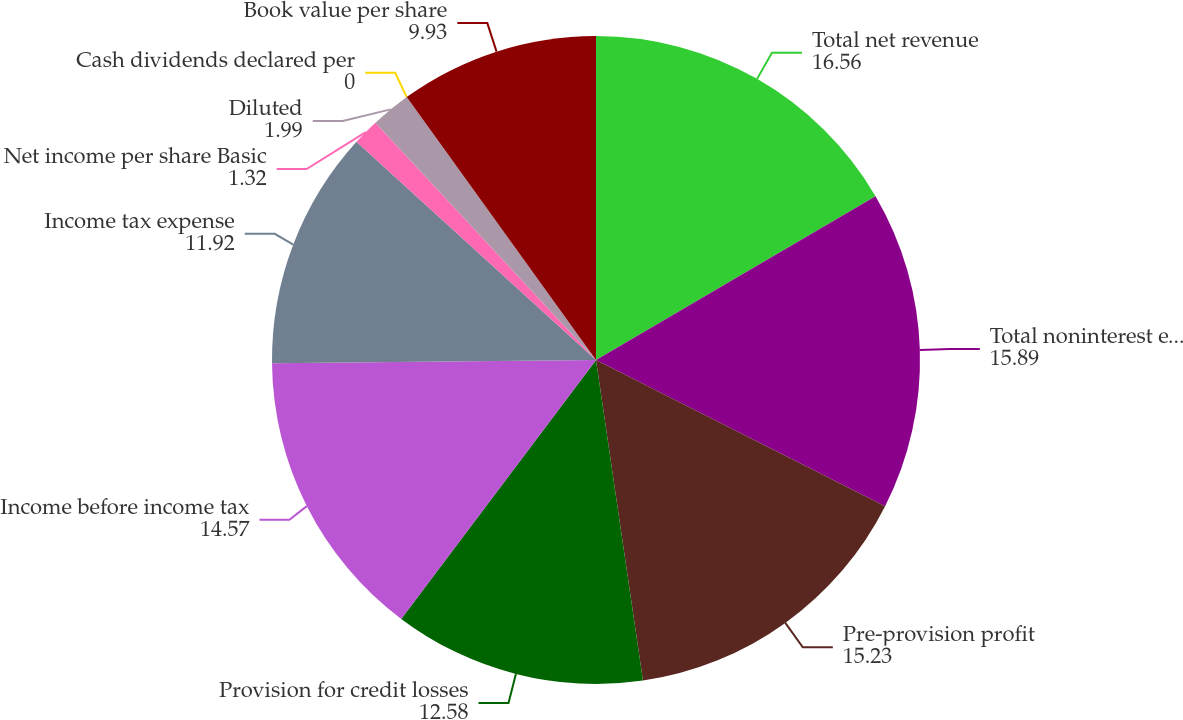Convert chart. <chart><loc_0><loc_0><loc_500><loc_500><pie_chart><fcel>Total net revenue<fcel>Total noninterest expense<fcel>Pre-provision profit<fcel>Provision for credit losses<fcel>Income before income tax<fcel>Income tax expense<fcel>Net income per share Basic<fcel>Diluted<fcel>Cash dividends declared per<fcel>Book value per share<nl><fcel>16.56%<fcel>15.89%<fcel>15.23%<fcel>12.58%<fcel>14.57%<fcel>11.92%<fcel>1.32%<fcel>1.99%<fcel>0.0%<fcel>9.93%<nl></chart> 